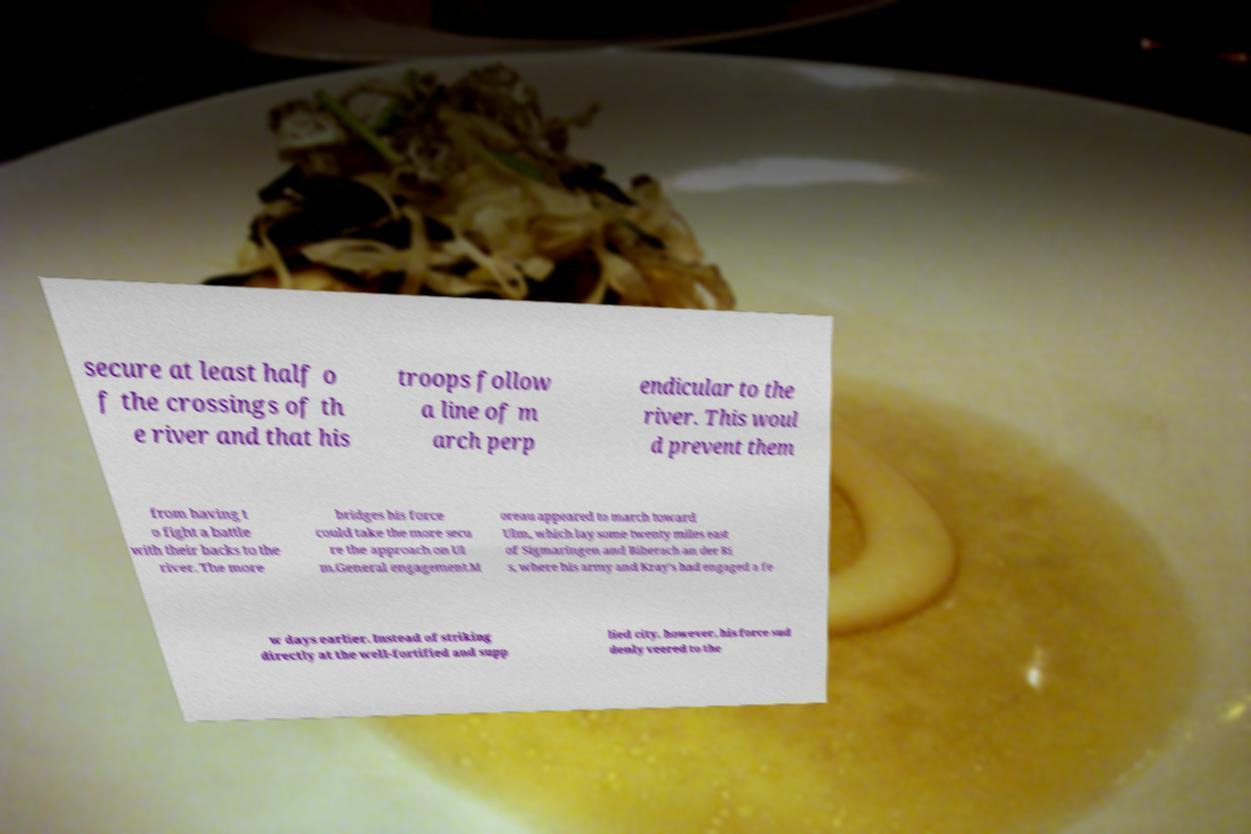What messages or text are displayed in this image? I need them in a readable, typed format. secure at least half o f the crossings of th e river and that his troops follow a line of m arch perp endicular to the river. This woul d prevent them from having t o fight a battle with their backs to the river. The more bridges his force could take the more secu re the approach on Ul m.General engagement.M oreau appeared to march toward Ulm, which lay some twenty miles east of Sigmaringen and Biberach an der Ri s, where his army and Kray's had engaged a fe w days earlier. Instead of striking directly at the well-fortified and supp lied city, however, his force sud denly veered to the 